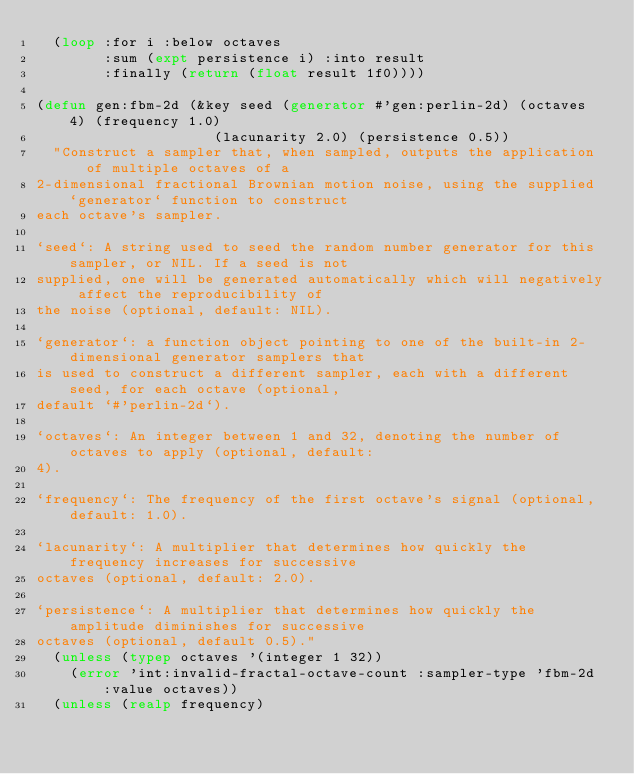Convert code to text. <code><loc_0><loc_0><loc_500><loc_500><_Lisp_>  (loop :for i :below octaves
        :sum (expt persistence i) :into result
        :finally (return (float result 1f0))))

(defun gen:fbm-2d (&key seed (generator #'gen:perlin-2d) (octaves 4) (frequency 1.0)
                     (lacunarity 2.0) (persistence 0.5))
  "Construct a sampler that, when sampled, outputs the application of multiple octaves of a
2-dimensional fractional Brownian motion noise, using the supplied `generator` function to construct
each octave's sampler.

`seed`: A string used to seed the random number generator for this sampler, or NIL. If a seed is not
supplied, one will be generated automatically which will negatively affect the reproducibility of
the noise (optional, default: NIL).

`generator`: a function object pointing to one of the built-in 2-dimensional generator samplers that
is used to construct a different sampler, each with a different seed, for each octave (optional,
default `#'perlin-2d`).

`octaves`: An integer between 1 and 32, denoting the number of octaves to apply (optional, default:
4).

`frequency`: The frequency of the first octave's signal (optional, default: 1.0).

`lacunarity`: A multiplier that determines how quickly the frequency increases for successive
octaves (optional, default: 2.0).

`persistence`: A multiplier that determines how quickly the amplitude diminishes for successive
octaves (optional, default 0.5)."
  (unless (typep octaves '(integer 1 32))
    (error 'int:invalid-fractal-octave-count :sampler-type 'fbm-2d :value octaves))
  (unless (realp frequency)</code> 